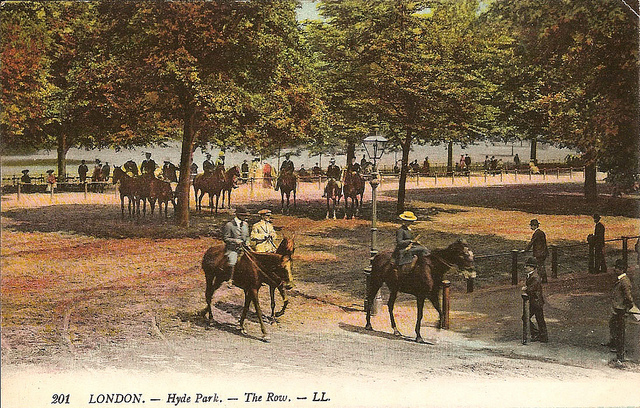Read and extract the text from this image. 201 LONDON Hyde Park The LL Row 